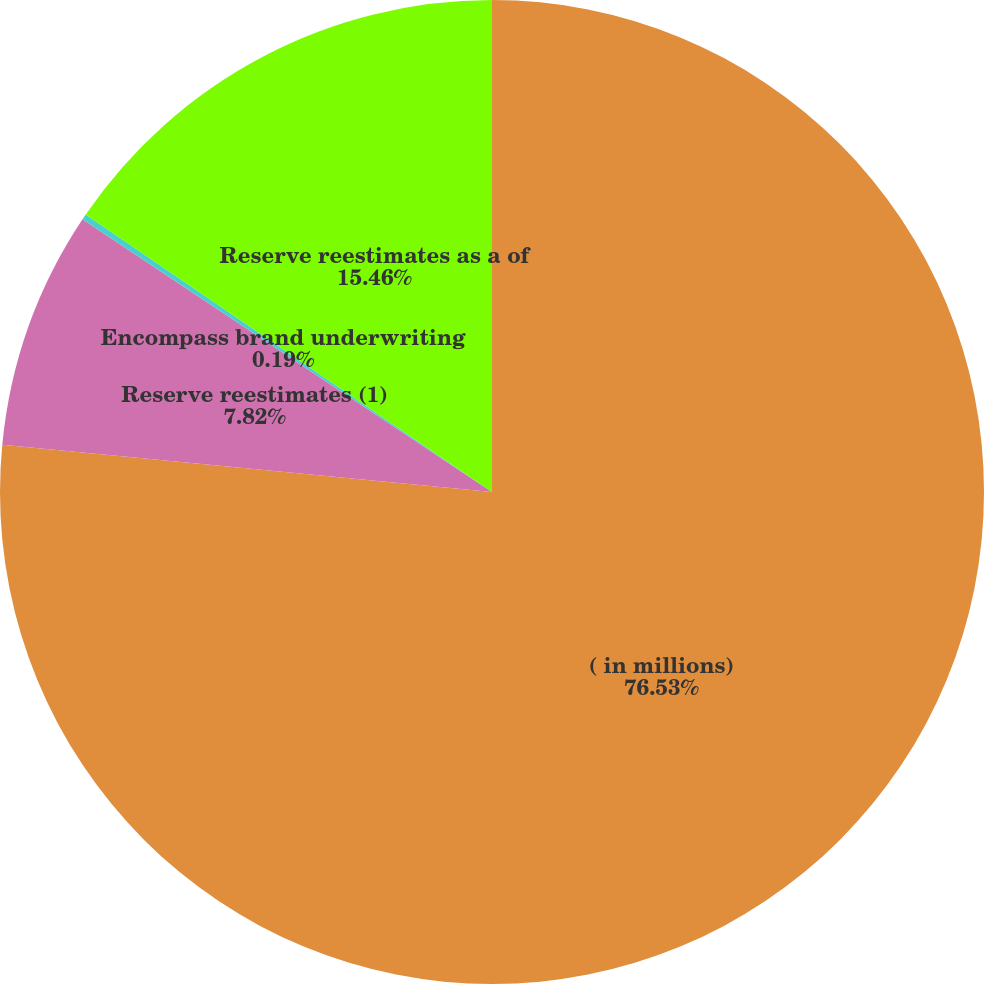<chart> <loc_0><loc_0><loc_500><loc_500><pie_chart><fcel>( in millions)<fcel>Reserve reestimates (1)<fcel>Encompass brand underwriting<fcel>Reserve reestimates as a of<nl><fcel>76.53%<fcel>7.82%<fcel>0.19%<fcel>15.46%<nl></chart> 